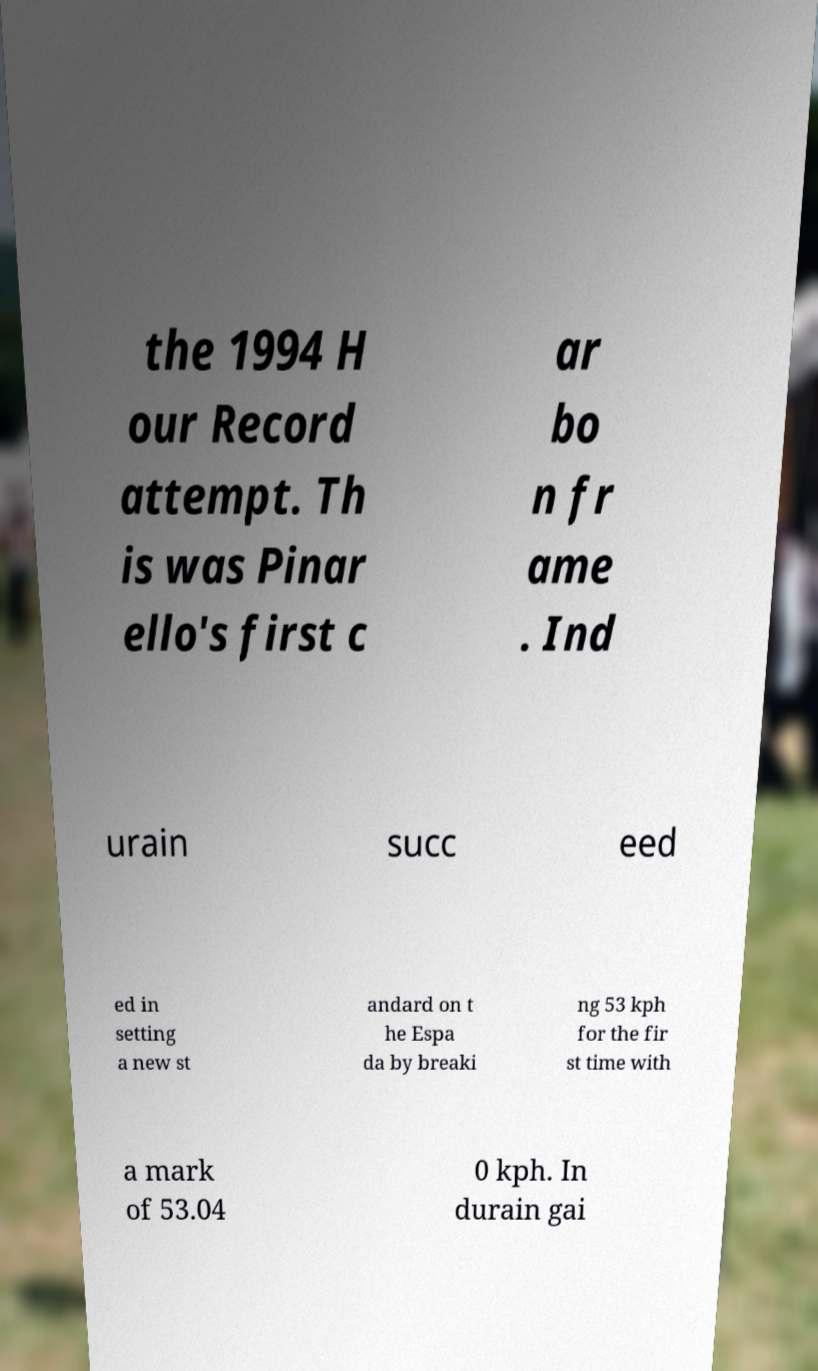Can you read and provide the text displayed in the image?This photo seems to have some interesting text. Can you extract and type it out for me? the 1994 H our Record attempt. Th is was Pinar ello's first c ar bo n fr ame . Ind urain succ eed ed in setting a new st andard on t he Espa da by breaki ng 53 kph for the fir st time with a mark of 53.04 0 kph. In durain gai 